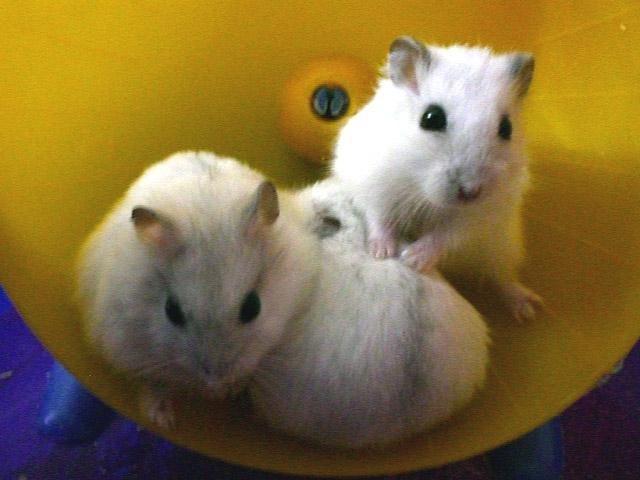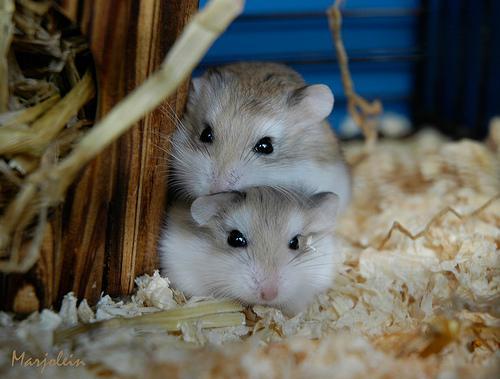The first image is the image on the left, the second image is the image on the right. Assess this claim about the two images: "In one image, a hamster is holding a bit of corn in its hands.". Correct or not? Answer yes or no. No. The first image is the image on the left, the second image is the image on the right. Analyze the images presented: Is the assertion "One hamster is eating a single kernel of corn." valid? Answer yes or no. No. 